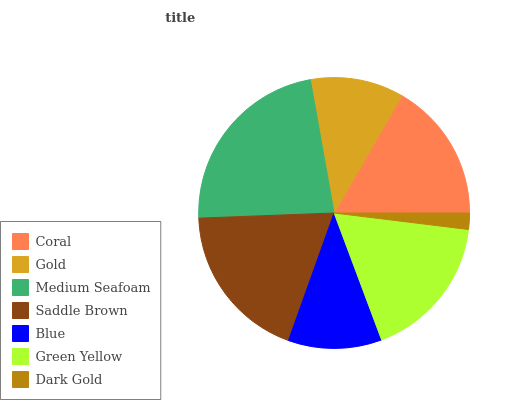Is Dark Gold the minimum?
Answer yes or no. Yes. Is Medium Seafoam the maximum?
Answer yes or no. Yes. Is Gold the minimum?
Answer yes or no. No. Is Gold the maximum?
Answer yes or no. No. Is Coral greater than Gold?
Answer yes or no. Yes. Is Gold less than Coral?
Answer yes or no. Yes. Is Gold greater than Coral?
Answer yes or no. No. Is Coral less than Gold?
Answer yes or no. No. Is Coral the high median?
Answer yes or no. Yes. Is Coral the low median?
Answer yes or no. Yes. Is Dark Gold the high median?
Answer yes or no. No. Is Dark Gold the low median?
Answer yes or no. No. 